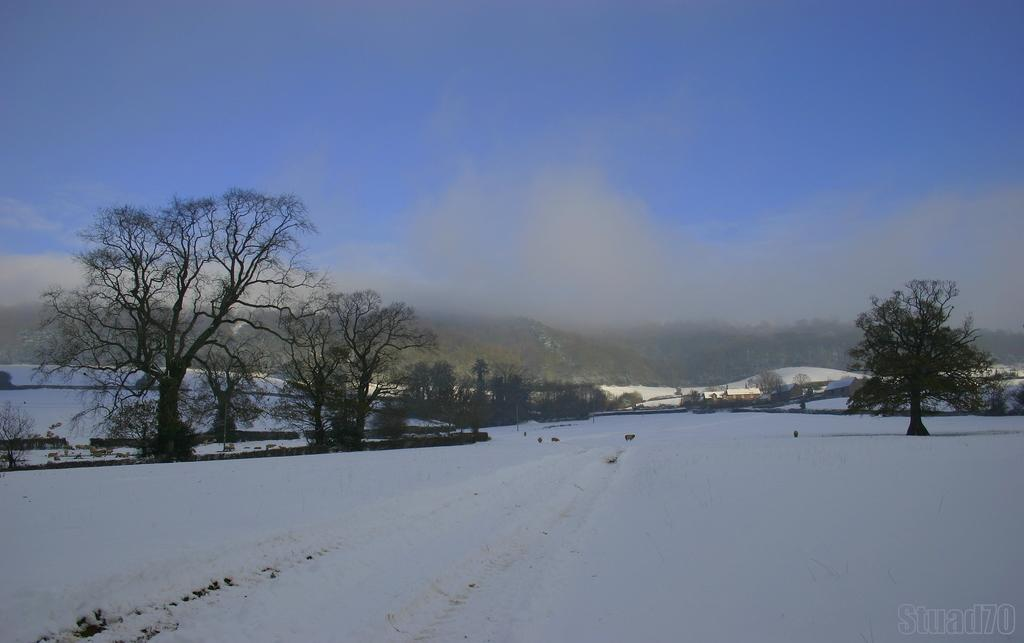What is present at the bottom of the image? There is snow at the bottom of the image. What can be seen in the background of the image? A: There are trees, houses, mountains, and clouds in the sky in the background of the image. What type of stem can be seen growing from the snow in the image? There are no stems present in the image; it features snow at the bottom and various elements in the background. 